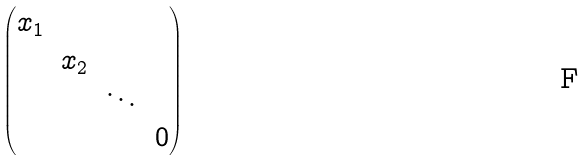<formula> <loc_0><loc_0><loc_500><loc_500>\begin{pmatrix} x _ { 1 } & & & \\ & x _ { 2 } & & \\ & & \ddots & \\ & & & 0 \end{pmatrix}</formula> 